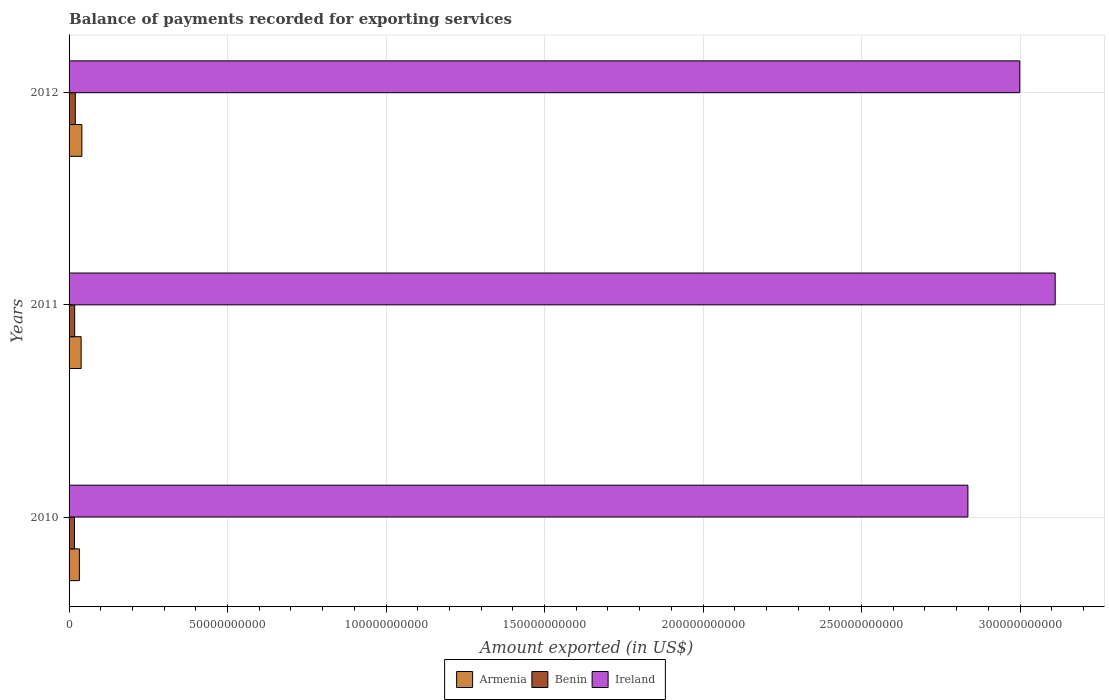How many groups of bars are there?
Give a very brief answer. 3. How many bars are there on the 3rd tick from the top?
Your answer should be very brief. 3. How many bars are there on the 2nd tick from the bottom?
Make the answer very short. 3. In how many cases, is the number of bars for a given year not equal to the number of legend labels?
Offer a very short reply. 0. What is the amount exported in Armenia in 2011?
Your answer should be very brief. 3.81e+09. Across all years, what is the maximum amount exported in Benin?
Give a very brief answer. 1.97e+09. Across all years, what is the minimum amount exported in Benin?
Make the answer very short. 1.71e+09. In which year was the amount exported in Benin maximum?
Offer a very short reply. 2012. In which year was the amount exported in Armenia minimum?
Provide a succinct answer. 2010. What is the total amount exported in Benin in the graph?
Offer a terse response. 5.44e+09. What is the difference between the amount exported in Armenia in 2011 and that in 2012?
Your answer should be compact. -2.25e+08. What is the difference between the amount exported in Ireland in 2010 and the amount exported in Benin in 2012?
Provide a succinct answer. 2.82e+11. What is the average amount exported in Armenia per year?
Provide a short and direct response. 3.70e+09. In the year 2010, what is the difference between the amount exported in Armenia and amount exported in Benin?
Make the answer very short. 1.55e+09. In how many years, is the amount exported in Benin greater than 180000000000 US$?
Provide a succinct answer. 0. What is the ratio of the amount exported in Benin in 2011 to that in 2012?
Provide a short and direct response. 0.9. Is the amount exported in Armenia in 2010 less than that in 2011?
Make the answer very short. Yes. What is the difference between the highest and the second highest amount exported in Benin?
Give a very brief answer. 2.03e+08. What is the difference between the highest and the lowest amount exported in Ireland?
Keep it short and to the point. 2.75e+1. Is the sum of the amount exported in Ireland in 2010 and 2012 greater than the maximum amount exported in Benin across all years?
Keep it short and to the point. Yes. What does the 3rd bar from the top in 2010 represents?
Your answer should be compact. Armenia. What does the 3rd bar from the bottom in 2011 represents?
Make the answer very short. Ireland. Is it the case that in every year, the sum of the amount exported in Ireland and amount exported in Armenia is greater than the amount exported in Benin?
Your answer should be very brief. Yes. Are all the bars in the graph horizontal?
Provide a succinct answer. Yes. How many years are there in the graph?
Provide a short and direct response. 3. What is the difference between two consecutive major ticks on the X-axis?
Offer a terse response. 5.00e+1. Does the graph contain any zero values?
Your response must be concise. No. What is the title of the graph?
Your answer should be very brief. Balance of payments recorded for exporting services. What is the label or title of the X-axis?
Your answer should be compact. Amount exported (in US$). What is the Amount exported (in US$) in Armenia in 2010?
Your answer should be very brief. 3.26e+09. What is the Amount exported (in US$) in Benin in 2010?
Your answer should be very brief. 1.71e+09. What is the Amount exported (in US$) in Ireland in 2010?
Ensure brevity in your answer.  2.84e+11. What is the Amount exported (in US$) of Armenia in 2011?
Your answer should be compact. 3.81e+09. What is the Amount exported (in US$) of Benin in 2011?
Your answer should be compact. 1.77e+09. What is the Amount exported (in US$) in Ireland in 2011?
Give a very brief answer. 3.11e+11. What is the Amount exported (in US$) of Armenia in 2012?
Offer a terse response. 4.03e+09. What is the Amount exported (in US$) of Benin in 2012?
Keep it short and to the point. 1.97e+09. What is the Amount exported (in US$) of Ireland in 2012?
Ensure brevity in your answer.  3.00e+11. Across all years, what is the maximum Amount exported (in US$) in Armenia?
Make the answer very short. 4.03e+09. Across all years, what is the maximum Amount exported (in US$) of Benin?
Your answer should be compact. 1.97e+09. Across all years, what is the maximum Amount exported (in US$) in Ireland?
Your response must be concise. 3.11e+11. Across all years, what is the minimum Amount exported (in US$) in Armenia?
Your answer should be compact. 3.26e+09. Across all years, what is the minimum Amount exported (in US$) in Benin?
Your answer should be compact. 1.71e+09. Across all years, what is the minimum Amount exported (in US$) of Ireland?
Provide a succinct answer. 2.84e+11. What is the total Amount exported (in US$) of Armenia in the graph?
Your answer should be compact. 1.11e+1. What is the total Amount exported (in US$) in Benin in the graph?
Keep it short and to the point. 5.44e+09. What is the total Amount exported (in US$) in Ireland in the graph?
Offer a very short reply. 8.95e+11. What is the difference between the Amount exported (in US$) in Armenia in 2010 and that in 2011?
Your answer should be compact. -5.48e+08. What is the difference between the Amount exported (in US$) in Benin in 2010 and that in 2011?
Provide a succinct answer. -5.81e+07. What is the difference between the Amount exported (in US$) in Ireland in 2010 and that in 2011?
Provide a short and direct response. -2.75e+1. What is the difference between the Amount exported (in US$) in Armenia in 2010 and that in 2012?
Give a very brief answer. -7.73e+08. What is the difference between the Amount exported (in US$) of Benin in 2010 and that in 2012?
Provide a short and direct response. -2.61e+08. What is the difference between the Amount exported (in US$) of Ireland in 2010 and that in 2012?
Offer a very short reply. -1.64e+1. What is the difference between the Amount exported (in US$) of Armenia in 2011 and that in 2012?
Provide a succinct answer. -2.25e+08. What is the difference between the Amount exported (in US$) in Benin in 2011 and that in 2012?
Offer a terse response. -2.03e+08. What is the difference between the Amount exported (in US$) in Ireland in 2011 and that in 2012?
Your response must be concise. 1.12e+1. What is the difference between the Amount exported (in US$) in Armenia in 2010 and the Amount exported (in US$) in Benin in 2011?
Make the answer very short. 1.49e+09. What is the difference between the Amount exported (in US$) of Armenia in 2010 and the Amount exported (in US$) of Ireland in 2011?
Offer a very short reply. -3.08e+11. What is the difference between the Amount exported (in US$) in Benin in 2010 and the Amount exported (in US$) in Ireland in 2011?
Keep it short and to the point. -3.09e+11. What is the difference between the Amount exported (in US$) of Armenia in 2010 and the Amount exported (in US$) of Benin in 2012?
Keep it short and to the point. 1.29e+09. What is the difference between the Amount exported (in US$) of Armenia in 2010 and the Amount exported (in US$) of Ireland in 2012?
Offer a very short reply. -2.97e+11. What is the difference between the Amount exported (in US$) in Benin in 2010 and the Amount exported (in US$) in Ireland in 2012?
Your response must be concise. -2.98e+11. What is the difference between the Amount exported (in US$) in Armenia in 2011 and the Amount exported (in US$) in Benin in 2012?
Make the answer very short. 1.84e+09. What is the difference between the Amount exported (in US$) in Armenia in 2011 and the Amount exported (in US$) in Ireland in 2012?
Ensure brevity in your answer.  -2.96e+11. What is the difference between the Amount exported (in US$) in Benin in 2011 and the Amount exported (in US$) in Ireland in 2012?
Ensure brevity in your answer.  -2.98e+11. What is the average Amount exported (in US$) in Armenia per year?
Provide a succinct answer. 3.70e+09. What is the average Amount exported (in US$) of Benin per year?
Offer a terse response. 1.81e+09. What is the average Amount exported (in US$) in Ireland per year?
Provide a short and direct response. 2.98e+11. In the year 2010, what is the difference between the Amount exported (in US$) in Armenia and Amount exported (in US$) in Benin?
Offer a terse response. 1.55e+09. In the year 2010, what is the difference between the Amount exported (in US$) in Armenia and Amount exported (in US$) in Ireland?
Offer a terse response. -2.80e+11. In the year 2010, what is the difference between the Amount exported (in US$) of Benin and Amount exported (in US$) of Ireland?
Give a very brief answer. -2.82e+11. In the year 2011, what is the difference between the Amount exported (in US$) in Armenia and Amount exported (in US$) in Benin?
Ensure brevity in your answer.  2.04e+09. In the year 2011, what is the difference between the Amount exported (in US$) in Armenia and Amount exported (in US$) in Ireland?
Offer a terse response. -3.07e+11. In the year 2011, what is the difference between the Amount exported (in US$) in Benin and Amount exported (in US$) in Ireland?
Provide a short and direct response. -3.09e+11. In the year 2012, what is the difference between the Amount exported (in US$) in Armenia and Amount exported (in US$) in Benin?
Make the answer very short. 2.06e+09. In the year 2012, what is the difference between the Amount exported (in US$) of Armenia and Amount exported (in US$) of Ireland?
Provide a short and direct response. -2.96e+11. In the year 2012, what is the difference between the Amount exported (in US$) of Benin and Amount exported (in US$) of Ireland?
Make the answer very short. -2.98e+11. What is the ratio of the Amount exported (in US$) of Armenia in 2010 to that in 2011?
Your response must be concise. 0.86. What is the ratio of the Amount exported (in US$) of Benin in 2010 to that in 2011?
Make the answer very short. 0.97. What is the ratio of the Amount exported (in US$) in Ireland in 2010 to that in 2011?
Your answer should be very brief. 0.91. What is the ratio of the Amount exported (in US$) of Armenia in 2010 to that in 2012?
Provide a short and direct response. 0.81. What is the ratio of the Amount exported (in US$) of Benin in 2010 to that in 2012?
Make the answer very short. 0.87. What is the ratio of the Amount exported (in US$) in Ireland in 2010 to that in 2012?
Your answer should be very brief. 0.95. What is the ratio of the Amount exported (in US$) of Armenia in 2011 to that in 2012?
Your answer should be very brief. 0.94. What is the ratio of the Amount exported (in US$) of Benin in 2011 to that in 2012?
Offer a very short reply. 0.9. What is the ratio of the Amount exported (in US$) of Ireland in 2011 to that in 2012?
Give a very brief answer. 1.04. What is the difference between the highest and the second highest Amount exported (in US$) in Armenia?
Ensure brevity in your answer.  2.25e+08. What is the difference between the highest and the second highest Amount exported (in US$) in Benin?
Offer a very short reply. 2.03e+08. What is the difference between the highest and the second highest Amount exported (in US$) of Ireland?
Your response must be concise. 1.12e+1. What is the difference between the highest and the lowest Amount exported (in US$) of Armenia?
Your response must be concise. 7.73e+08. What is the difference between the highest and the lowest Amount exported (in US$) of Benin?
Offer a terse response. 2.61e+08. What is the difference between the highest and the lowest Amount exported (in US$) in Ireland?
Give a very brief answer. 2.75e+1. 